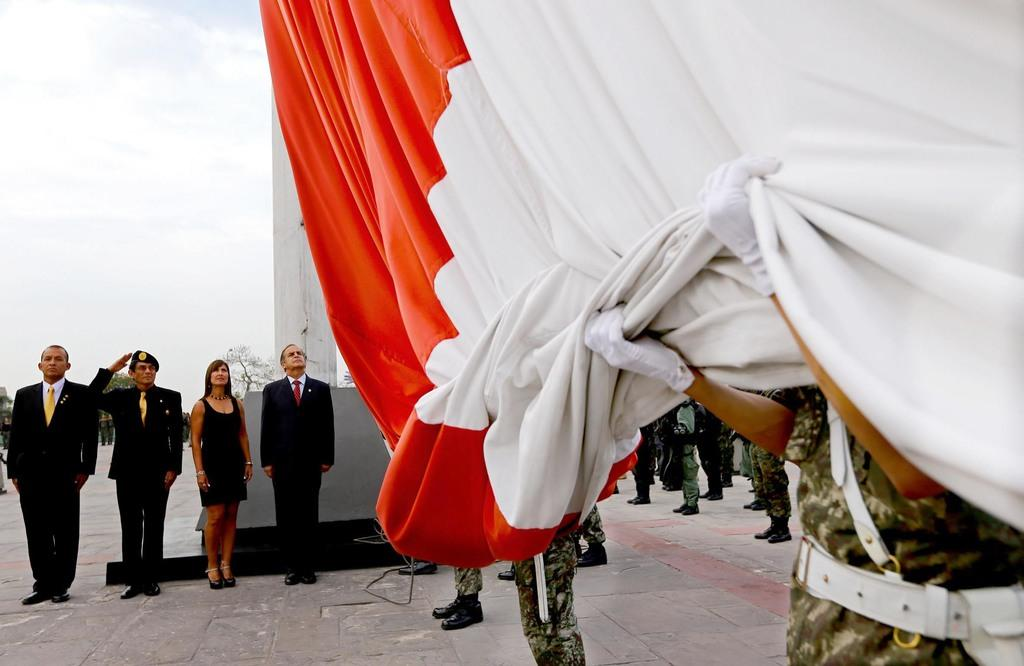How many people are present in the image? There are four persons standing in the image. What is one of the persons holding in the image? There is a person holding a cloth in the image. Can you describe the background of the image? There is a group of people standing in the background of the image, along with a tree and the sky. What direction is the rabbit facing in the image? There is no rabbit present in the image. What type of vacation are the people planning in the image? There is no indication of a vacation in the image; it simply shows four people standing together. 